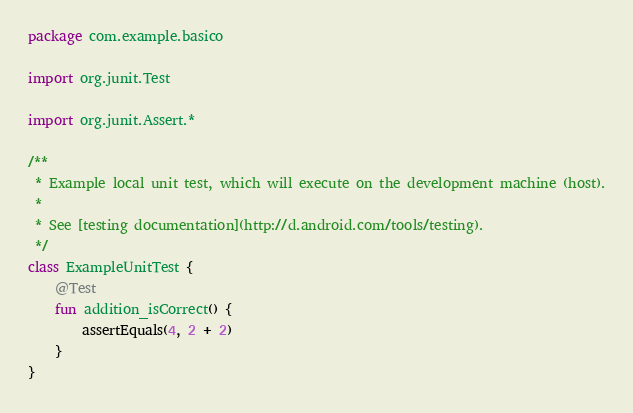Convert code to text. <code><loc_0><loc_0><loc_500><loc_500><_Kotlin_>package com.example.basico

import org.junit.Test

import org.junit.Assert.*

/**
 * Example local unit test, which will execute on the development machine (host).
 *
 * See [testing documentation](http://d.android.com/tools/testing).
 */
class ExampleUnitTest {
    @Test
    fun addition_isCorrect() {
        assertEquals(4, 2 + 2)
    }
}</code> 